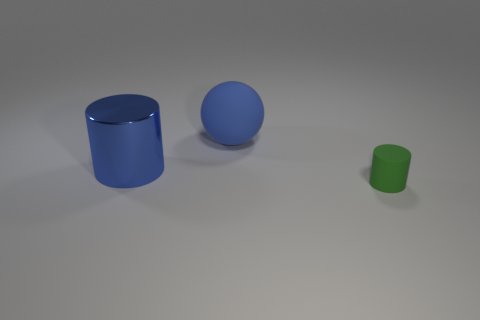What is the shape of the rubber object that is the same color as the large cylinder? sphere 